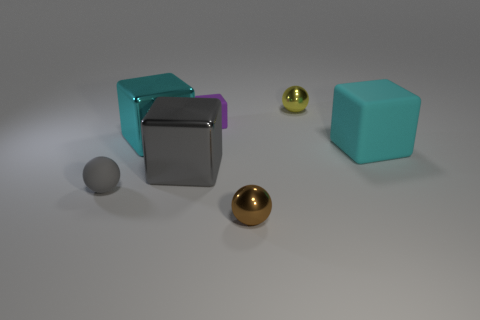There is a brown metal sphere; are there any tiny matte cubes behind it?
Keep it short and to the point. Yes. What is the shape of the large cyan metal thing?
Your answer should be compact. Cube. What number of things are shiny objects that are behind the rubber ball or small gray rubber spheres?
Give a very brief answer. 4. What number of other things are there of the same color as the matte sphere?
Ensure brevity in your answer.  1. Do the small cube and the small metal object that is in front of the cyan metallic block have the same color?
Ensure brevity in your answer.  No. What color is the other metallic thing that is the same shape as the gray shiny thing?
Make the answer very short. Cyan. Does the gray cube have the same material as the sphere that is on the right side of the brown ball?
Make the answer very short. Yes. The big matte cube has what color?
Provide a succinct answer. Cyan. There is a tiny shiny ball that is on the right side of the metallic sphere that is in front of the shiny thing behind the small purple cube; what color is it?
Make the answer very short. Yellow. Does the tiny brown metal thing have the same shape as the gray object in front of the gray metallic thing?
Ensure brevity in your answer.  Yes. 